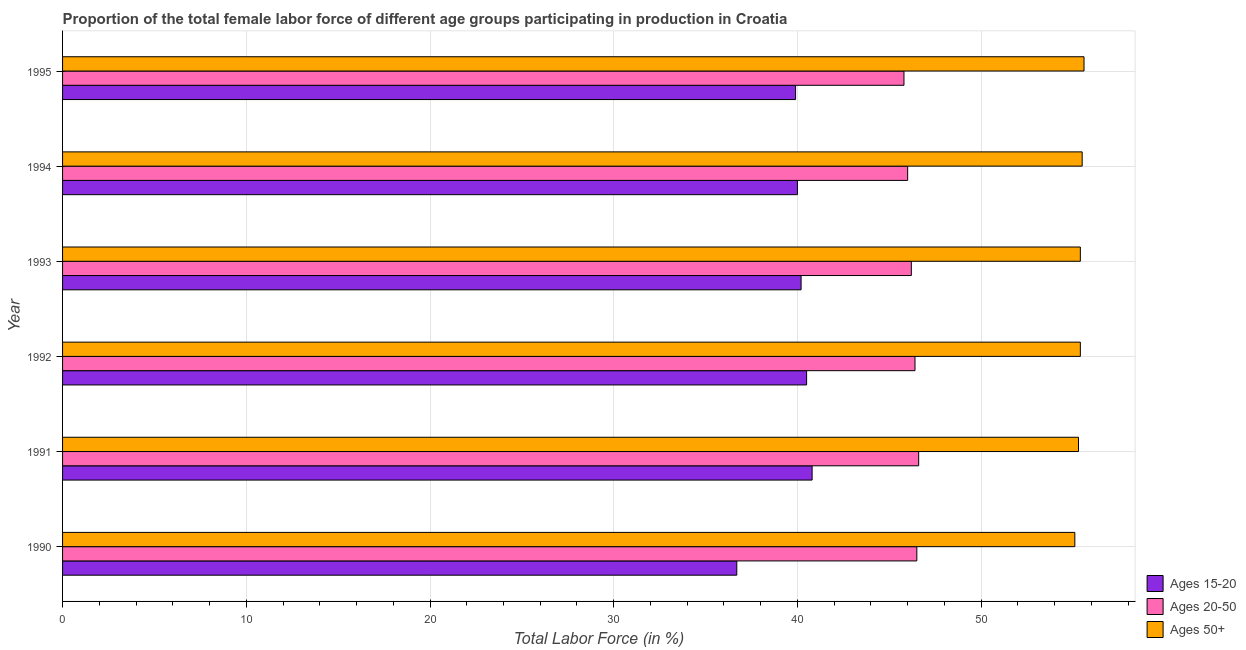How many groups of bars are there?
Offer a terse response. 6. Are the number of bars per tick equal to the number of legend labels?
Provide a short and direct response. Yes. How many bars are there on the 6th tick from the bottom?
Provide a short and direct response. 3. What is the label of the 4th group of bars from the top?
Offer a terse response. 1992. What is the percentage of female labor force within the age group 15-20 in 1992?
Your answer should be very brief. 40.5. Across all years, what is the maximum percentage of female labor force above age 50?
Keep it short and to the point. 55.6. Across all years, what is the minimum percentage of female labor force within the age group 15-20?
Keep it short and to the point. 36.7. In which year was the percentage of female labor force within the age group 15-20 minimum?
Your answer should be compact. 1990. What is the total percentage of female labor force within the age group 20-50 in the graph?
Your answer should be compact. 277.5. What is the difference between the percentage of female labor force within the age group 15-20 in 1991 and that in 1994?
Offer a terse response. 0.8. What is the difference between the percentage of female labor force above age 50 in 1992 and the percentage of female labor force within the age group 20-50 in 1993?
Give a very brief answer. 9.2. What is the average percentage of female labor force within the age group 20-50 per year?
Your response must be concise. 46.25. In the year 1994, what is the difference between the percentage of female labor force within the age group 20-50 and percentage of female labor force within the age group 15-20?
Provide a succinct answer. 6. In how many years, is the percentage of female labor force above age 50 greater than 42 %?
Provide a succinct answer. 6. What is the ratio of the percentage of female labor force above age 50 in 1990 to that in 1991?
Your answer should be very brief. 1. Is the difference between the percentage of female labor force within the age group 15-20 in 1993 and 1995 greater than the difference between the percentage of female labor force above age 50 in 1993 and 1995?
Provide a short and direct response. Yes. What is the difference between the highest and the second highest percentage of female labor force within the age group 15-20?
Provide a short and direct response. 0.3. Is the sum of the percentage of female labor force above age 50 in 1991 and 1993 greater than the maximum percentage of female labor force within the age group 15-20 across all years?
Keep it short and to the point. Yes. What does the 3rd bar from the top in 1991 represents?
Keep it short and to the point. Ages 15-20. What does the 3rd bar from the bottom in 1995 represents?
Give a very brief answer. Ages 50+. How many bars are there?
Offer a very short reply. 18. Are all the bars in the graph horizontal?
Your answer should be very brief. Yes. How many years are there in the graph?
Offer a very short reply. 6. What is the difference between two consecutive major ticks on the X-axis?
Offer a terse response. 10. Are the values on the major ticks of X-axis written in scientific E-notation?
Ensure brevity in your answer.  No. Where does the legend appear in the graph?
Your answer should be very brief. Bottom right. How many legend labels are there?
Offer a very short reply. 3. What is the title of the graph?
Give a very brief answer. Proportion of the total female labor force of different age groups participating in production in Croatia. What is the label or title of the Y-axis?
Offer a very short reply. Year. What is the Total Labor Force (in %) of Ages 15-20 in 1990?
Offer a very short reply. 36.7. What is the Total Labor Force (in %) in Ages 20-50 in 1990?
Offer a terse response. 46.5. What is the Total Labor Force (in %) in Ages 50+ in 1990?
Ensure brevity in your answer.  55.1. What is the Total Labor Force (in %) in Ages 15-20 in 1991?
Make the answer very short. 40.8. What is the Total Labor Force (in %) in Ages 20-50 in 1991?
Keep it short and to the point. 46.6. What is the Total Labor Force (in %) of Ages 50+ in 1991?
Make the answer very short. 55.3. What is the Total Labor Force (in %) of Ages 15-20 in 1992?
Offer a terse response. 40.5. What is the Total Labor Force (in %) in Ages 20-50 in 1992?
Provide a succinct answer. 46.4. What is the Total Labor Force (in %) in Ages 50+ in 1992?
Provide a short and direct response. 55.4. What is the Total Labor Force (in %) in Ages 15-20 in 1993?
Give a very brief answer. 40.2. What is the Total Labor Force (in %) of Ages 20-50 in 1993?
Ensure brevity in your answer.  46.2. What is the Total Labor Force (in %) in Ages 50+ in 1993?
Your response must be concise. 55.4. What is the Total Labor Force (in %) of Ages 20-50 in 1994?
Keep it short and to the point. 46. What is the Total Labor Force (in %) of Ages 50+ in 1994?
Offer a very short reply. 55.5. What is the Total Labor Force (in %) of Ages 15-20 in 1995?
Make the answer very short. 39.9. What is the Total Labor Force (in %) of Ages 20-50 in 1995?
Keep it short and to the point. 45.8. What is the Total Labor Force (in %) of Ages 50+ in 1995?
Your answer should be very brief. 55.6. Across all years, what is the maximum Total Labor Force (in %) of Ages 15-20?
Your answer should be very brief. 40.8. Across all years, what is the maximum Total Labor Force (in %) of Ages 20-50?
Make the answer very short. 46.6. Across all years, what is the maximum Total Labor Force (in %) in Ages 50+?
Keep it short and to the point. 55.6. Across all years, what is the minimum Total Labor Force (in %) of Ages 15-20?
Keep it short and to the point. 36.7. Across all years, what is the minimum Total Labor Force (in %) in Ages 20-50?
Keep it short and to the point. 45.8. Across all years, what is the minimum Total Labor Force (in %) in Ages 50+?
Your answer should be very brief. 55.1. What is the total Total Labor Force (in %) of Ages 15-20 in the graph?
Your answer should be compact. 238.1. What is the total Total Labor Force (in %) of Ages 20-50 in the graph?
Ensure brevity in your answer.  277.5. What is the total Total Labor Force (in %) of Ages 50+ in the graph?
Give a very brief answer. 332.3. What is the difference between the Total Labor Force (in %) of Ages 20-50 in 1990 and that in 1991?
Your answer should be very brief. -0.1. What is the difference between the Total Labor Force (in %) in Ages 50+ in 1990 and that in 1991?
Provide a short and direct response. -0.2. What is the difference between the Total Labor Force (in %) in Ages 20-50 in 1990 and that in 1992?
Your response must be concise. 0.1. What is the difference between the Total Labor Force (in %) of Ages 15-20 in 1990 and that in 1993?
Keep it short and to the point. -3.5. What is the difference between the Total Labor Force (in %) in Ages 20-50 in 1990 and that in 1993?
Give a very brief answer. 0.3. What is the difference between the Total Labor Force (in %) of Ages 50+ in 1990 and that in 1993?
Give a very brief answer. -0.3. What is the difference between the Total Labor Force (in %) in Ages 20-50 in 1990 and that in 1994?
Keep it short and to the point. 0.5. What is the difference between the Total Labor Force (in %) in Ages 50+ in 1990 and that in 1995?
Your answer should be very brief. -0.5. What is the difference between the Total Labor Force (in %) in Ages 15-20 in 1991 and that in 1992?
Your answer should be very brief. 0.3. What is the difference between the Total Labor Force (in %) of Ages 20-50 in 1991 and that in 1993?
Provide a short and direct response. 0.4. What is the difference between the Total Labor Force (in %) of Ages 50+ in 1991 and that in 1993?
Your answer should be compact. -0.1. What is the difference between the Total Labor Force (in %) of Ages 15-20 in 1991 and that in 1994?
Keep it short and to the point. 0.8. What is the difference between the Total Labor Force (in %) in Ages 20-50 in 1991 and that in 1994?
Ensure brevity in your answer.  0.6. What is the difference between the Total Labor Force (in %) of Ages 50+ in 1991 and that in 1995?
Your response must be concise. -0.3. What is the difference between the Total Labor Force (in %) in Ages 15-20 in 1992 and that in 1993?
Give a very brief answer. 0.3. What is the difference between the Total Labor Force (in %) in Ages 50+ in 1992 and that in 1993?
Your response must be concise. 0. What is the difference between the Total Labor Force (in %) in Ages 15-20 in 1992 and that in 1994?
Offer a very short reply. 0.5. What is the difference between the Total Labor Force (in %) in Ages 15-20 in 1992 and that in 1995?
Provide a short and direct response. 0.6. What is the difference between the Total Labor Force (in %) of Ages 20-50 in 1992 and that in 1995?
Provide a short and direct response. 0.6. What is the difference between the Total Labor Force (in %) in Ages 15-20 in 1993 and that in 1994?
Make the answer very short. 0.2. What is the difference between the Total Labor Force (in %) in Ages 20-50 in 1993 and that in 1994?
Provide a succinct answer. 0.2. What is the difference between the Total Labor Force (in %) in Ages 50+ in 1993 and that in 1994?
Provide a succinct answer. -0.1. What is the difference between the Total Labor Force (in %) in Ages 20-50 in 1993 and that in 1995?
Make the answer very short. 0.4. What is the difference between the Total Labor Force (in %) of Ages 50+ in 1993 and that in 1995?
Your answer should be compact. -0.2. What is the difference between the Total Labor Force (in %) in Ages 15-20 in 1990 and the Total Labor Force (in %) in Ages 50+ in 1991?
Offer a terse response. -18.6. What is the difference between the Total Labor Force (in %) in Ages 15-20 in 1990 and the Total Labor Force (in %) in Ages 50+ in 1992?
Provide a short and direct response. -18.7. What is the difference between the Total Labor Force (in %) of Ages 15-20 in 1990 and the Total Labor Force (in %) of Ages 20-50 in 1993?
Give a very brief answer. -9.5. What is the difference between the Total Labor Force (in %) of Ages 15-20 in 1990 and the Total Labor Force (in %) of Ages 50+ in 1993?
Offer a very short reply. -18.7. What is the difference between the Total Labor Force (in %) in Ages 20-50 in 1990 and the Total Labor Force (in %) in Ages 50+ in 1993?
Give a very brief answer. -8.9. What is the difference between the Total Labor Force (in %) in Ages 15-20 in 1990 and the Total Labor Force (in %) in Ages 50+ in 1994?
Offer a terse response. -18.8. What is the difference between the Total Labor Force (in %) of Ages 20-50 in 1990 and the Total Labor Force (in %) of Ages 50+ in 1994?
Provide a succinct answer. -9. What is the difference between the Total Labor Force (in %) in Ages 15-20 in 1990 and the Total Labor Force (in %) in Ages 20-50 in 1995?
Provide a short and direct response. -9.1. What is the difference between the Total Labor Force (in %) in Ages 15-20 in 1990 and the Total Labor Force (in %) in Ages 50+ in 1995?
Your answer should be compact. -18.9. What is the difference between the Total Labor Force (in %) in Ages 20-50 in 1990 and the Total Labor Force (in %) in Ages 50+ in 1995?
Offer a very short reply. -9.1. What is the difference between the Total Labor Force (in %) in Ages 15-20 in 1991 and the Total Labor Force (in %) in Ages 20-50 in 1992?
Ensure brevity in your answer.  -5.6. What is the difference between the Total Labor Force (in %) in Ages 15-20 in 1991 and the Total Labor Force (in %) in Ages 50+ in 1992?
Offer a terse response. -14.6. What is the difference between the Total Labor Force (in %) in Ages 20-50 in 1991 and the Total Labor Force (in %) in Ages 50+ in 1992?
Make the answer very short. -8.8. What is the difference between the Total Labor Force (in %) in Ages 15-20 in 1991 and the Total Labor Force (in %) in Ages 50+ in 1993?
Your response must be concise. -14.6. What is the difference between the Total Labor Force (in %) in Ages 20-50 in 1991 and the Total Labor Force (in %) in Ages 50+ in 1993?
Your response must be concise. -8.8. What is the difference between the Total Labor Force (in %) of Ages 15-20 in 1991 and the Total Labor Force (in %) of Ages 50+ in 1994?
Your response must be concise. -14.7. What is the difference between the Total Labor Force (in %) of Ages 20-50 in 1991 and the Total Labor Force (in %) of Ages 50+ in 1994?
Ensure brevity in your answer.  -8.9. What is the difference between the Total Labor Force (in %) in Ages 15-20 in 1991 and the Total Labor Force (in %) in Ages 20-50 in 1995?
Your answer should be very brief. -5. What is the difference between the Total Labor Force (in %) in Ages 15-20 in 1991 and the Total Labor Force (in %) in Ages 50+ in 1995?
Your response must be concise. -14.8. What is the difference between the Total Labor Force (in %) in Ages 15-20 in 1992 and the Total Labor Force (in %) in Ages 50+ in 1993?
Give a very brief answer. -14.9. What is the difference between the Total Labor Force (in %) of Ages 20-50 in 1992 and the Total Labor Force (in %) of Ages 50+ in 1993?
Make the answer very short. -9. What is the difference between the Total Labor Force (in %) in Ages 15-20 in 1992 and the Total Labor Force (in %) in Ages 20-50 in 1994?
Ensure brevity in your answer.  -5.5. What is the difference between the Total Labor Force (in %) in Ages 15-20 in 1992 and the Total Labor Force (in %) in Ages 50+ in 1994?
Ensure brevity in your answer.  -15. What is the difference between the Total Labor Force (in %) of Ages 20-50 in 1992 and the Total Labor Force (in %) of Ages 50+ in 1994?
Ensure brevity in your answer.  -9.1. What is the difference between the Total Labor Force (in %) in Ages 15-20 in 1992 and the Total Labor Force (in %) in Ages 20-50 in 1995?
Your response must be concise. -5.3. What is the difference between the Total Labor Force (in %) of Ages 15-20 in 1992 and the Total Labor Force (in %) of Ages 50+ in 1995?
Your answer should be compact. -15.1. What is the difference between the Total Labor Force (in %) of Ages 20-50 in 1992 and the Total Labor Force (in %) of Ages 50+ in 1995?
Provide a succinct answer. -9.2. What is the difference between the Total Labor Force (in %) in Ages 15-20 in 1993 and the Total Labor Force (in %) in Ages 20-50 in 1994?
Your answer should be very brief. -5.8. What is the difference between the Total Labor Force (in %) of Ages 15-20 in 1993 and the Total Labor Force (in %) of Ages 50+ in 1994?
Ensure brevity in your answer.  -15.3. What is the difference between the Total Labor Force (in %) of Ages 20-50 in 1993 and the Total Labor Force (in %) of Ages 50+ in 1994?
Offer a very short reply. -9.3. What is the difference between the Total Labor Force (in %) of Ages 15-20 in 1993 and the Total Labor Force (in %) of Ages 50+ in 1995?
Keep it short and to the point. -15.4. What is the difference between the Total Labor Force (in %) in Ages 15-20 in 1994 and the Total Labor Force (in %) in Ages 20-50 in 1995?
Make the answer very short. -5.8. What is the difference between the Total Labor Force (in %) in Ages 15-20 in 1994 and the Total Labor Force (in %) in Ages 50+ in 1995?
Make the answer very short. -15.6. What is the difference between the Total Labor Force (in %) of Ages 20-50 in 1994 and the Total Labor Force (in %) of Ages 50+ in 1995?
Your response must be concise. -9.6. What is the average Total Labor Force (in %) of Ages 15-20 per year?
Your response must be concise. 39.68. What is the average Total Labor Force (in %) of Ages 20-50 per year?
Provide a short and direct response. 46.25. What is the average Total Labor Force (in %) in Ages 50+ per year?
Offer a terse response. 55.38. In the year 1990, what is the difference between the Total Labor Force (in %) of Ages 15-20 and Total Labor Force (in %) of Ages 50+?
Offer a terse response. -18.4. In the year 1991, what is the difference between the Total Labor Force (in %) of Ages 15-20 and Total Labor Force (in %) of Ages 20-50?
Ensure brevity in your answer.  -5.8. In the year 1991, what is the difference between the Total Labor Force (in %) in Ages 15-20 and Total Labor Force (in %) in Ages 50+?
Offer a terse response. -14.5. In the year 1991, what is the difference between the Total Labor Force (in %) of Ages 20-50 and Total Labor Force (in %) of Ages 50+?
Keep it short and to the point. -8.7. In the year 1992, what is the difference between the Total Labor Force (in %) in Ages 15-20 and Total Labor Force (in %) in Ages 20-50?
Your response must be concise. -5.9. In the year 1992, what is the difference between the Total Labor Force (in %) in Ages 15-20 and Total Labor Force (in %) in Ages 50+?
Provide a short and direct response. -14.9. In the year 1992, what is the difference between the Total Labor Force (in %) in Ages 20-50 and Total Labor Force (in %) in Ages 50+?
Make the answer very short. -9. In the year 1993, what is the difference between the Total Labor Force (in %) of Ages 15-20 and Total Labor Force (in %) of Ages 50+?
Offer a terse response. -15.2. In the year 1993, what is the difference between the Total Labor Force (in %) of Ages 20-50 and Total Labor Force (in %) of Ages 50+?
Your answer should be very brief. -9.2. In the year 1994, what is the difference between the Total Labor Force (in %) in Ages 15-20 and Total Labor Force (in %) in Ages 50+?
Make the answer very short. -15.5. In the year 1995, what is the difference between the Total Labor Force (in %) in Ages 15-20 and Total Labor Force (in %) in Ages 50+?
Your response must be concise. -15.7. What is the ratio of the Total Labor Force (in %) of Ages 15-20 in 1990 to that in 1991?
Give a very brief answer. 0.9. What is the ratio of the Total Labor Force (in %) in Ages 15-20 in 1990 to that in 1992?
Provide a short and direct response. 0.91. What is the ratio of the Total Labor Force (in %) of Ages 50+ in 1990 to that in 1992?
Provide a succinct answer. 0.99. What is the ratio of the Total Labor Force (in %) of Ages 15-20 in 1990 to that in 1993?
Give a very brief answer. 0.91. What is the ratio of the Total Labor Force (in %) of Ages 15-20 in 1990 to that in 1994?
Offer a terse response. 0.92. What is the ratio of the Total Labor Force (in %) of Ages 20-50 in 1990 to that in 1994?
Provide a succinct answer. 1.01. What is the ratio of the Total Labor Force (in %) of Ages 15-20 in 1990 to that in 1995?
Your answer should be very brief. 0.92. What is the ratio of the Total Labor Force (in %) in Ages 20-50 in 1990 to that in 1995?
Your response must be concise. 1.02. What is the ratio of the Total Labor Force (in %) in Ages 15-20 in 1991 to that in 1992?
Your answer should be very brief. 1.01. What is the ratio of the Total Labor Force (in %) of Ages 50+ in 1991 to that in 1992?
Provide a succinct answer. 1. What is the ratio of the Total Labor Force (in %) in Ages 15-20 in 1991 to that in 1993?
Make the answer very short. 1.01. What is the ratio of the Total Labor Force (in %) of Ages 20-50 in 1991 to that in 1993?
Provide a succinct answer. 1.01. What is the ratio of the Total Labor Force (in %) of Ages 50+ in 1991 to that in 1993?
Keep it short and to the point. 1. What is the ratio of the Total Labor Force (in %) in Ages 15-20 in 1991 to that in 1994?
Provide a short and direct response. 1.02. What is the ratio of the Total Labor Force (in %) in Ages 50+ in 1991 to that in 1994?
Provide a succinct answer. 1. What is the ratio of the Total Labor Force (in %) in Ages 15-20 in 1991 to that in 1995?
Give a very brief answer. 1.02. What is the ratio of the Total Labor Force (in %) in Ages 20-50 in 1991 to that in 1995?
Provide a short and direct response. 1.02. What is the ratio of the Total Labor Force (in %) in Ages 15-20 in 1992 to that in 1993?
Your answer should be very brief. 1.01. What is the ratio of the Total Labor Force (in %) in Ages 15-20 in 1992 to that in 1994?
Offer a terse response. 1.01. What is the ratio of the Total Labor Force (in %) of Ages 20-50 in 1992 to that in 1994?
Offer a terse response. 1.01. What is the ratio of the Total Labor Force (in %) of Ages 50+ in 1992 to that in 1994?
Offer a terse response. 1. What is the ratio of the Total Labor Force (in %) of Ages 20-50 in 1992 to that in 1995?
Offer a terse response. 1.01. What is the ratio of the Total Labor Force (in %) of Ages 15-20 in 1993 to that in 1995?
Provide a short and direct response. 1.01. What is the ratio of the Total Labor Force (in %) of Ages 20-50 in 1993 to that in 1995?
Keep it short and to the point. 1.01. What is the ratio of the Total Labor Force (in %) of Ages 15-20 in 1994 to that in 1995?
Provide a succinct answer. 1. What is the ratio of the Total Labor Force (in %) in Ages 50+ in 1994 to that in 1995?
Your answer should be very brief. 1. What is the difference between the highest and the second highest Total Labor Force (in %) of Ages 50+?
Offer a terse response. 0.1. What is the difference between the highest and the lowest Total Labor Force (in %) of Ages 15-20?
Your response must be concise. 4.1. What is the difference between the highest and the lowest Total Labor Force (in %) in Ages 20-50?
Make the answer very short. 0.8. 